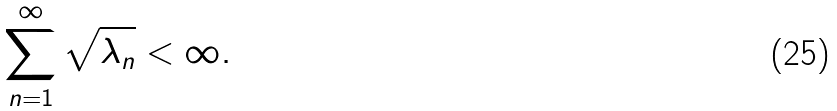Convert formula to latex. <formula><loc_0><loc_0><loc_500><loc_500>\sum ^ { \infty } _ { n = 1 } \sqrt { \lambda _ { n } } < \infty .</formula> 